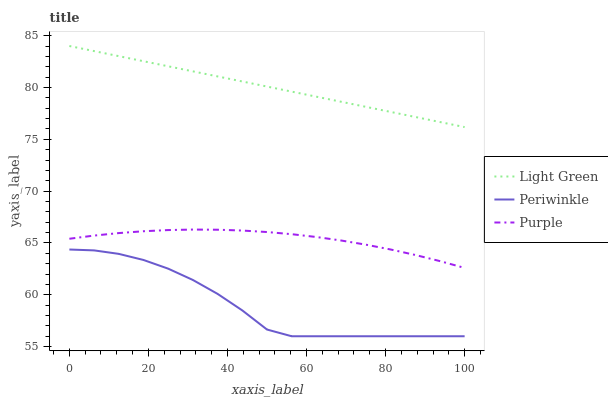Does Periwinkle have the minimum area under the curve?
Answer yes or no. Yes. Does Light Green have the maximum area under the curve?
Answer yes or no. Yes. Does Light Green have the minimum area under the curve?
Answer yes or no. No. Does Periwinkle have the maximum area under the curve?
Answer yes or no. No. Is Light Green the smoothest?
Answer yes or no. Yes. Is Periwinkle the roughest?
Answer yes or no. Yes. Is Periwinkle the smoothest?
Answer yes or no. No. Is Light Green the roughest?
Answer yes or no. No. Does Light Green have the lowest value?
Answer yes or no. No. Does Light Green have the highest value?
Answer yes or no. Yes. Does Periwinkle have the highest value?
Answer yes or no. No. Is Purple less than Light Green?
Answer yes or no. Yes. Is Light Green greater than Purple?
Answer yes or no. Yes. Does Purple intersect Light Green?
Answer yes or no. No. 